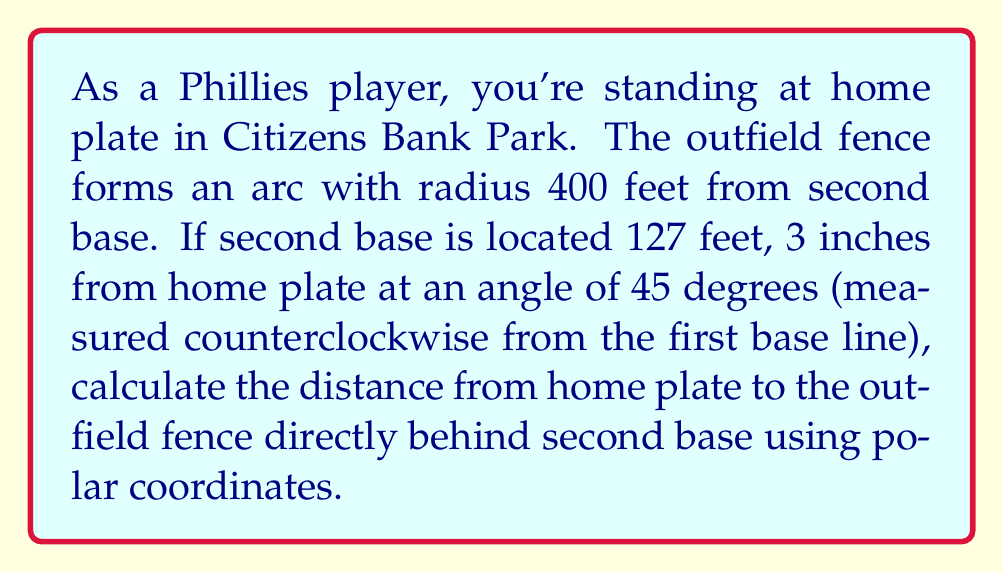What is the answer to this math problem? To solve this problem, we'll use polar coordinates and follow these steps:

1) First, we need to convert the given information into polar coordinates with home plate as the origin.

2) The position of second base in polar coordinates:
   $r_1 = 127.25$ feet (127 feet, 3 inches)
   $\theta_1 = 45°$

3) The outfield fence forms an arc centered at second base with radius 400 feet. We need to find the point on this arc that's directly behind second base from home plate's perspective.

4) To do this, we'll use the polar form of the equation of a circle:
   $r^2 + r_1^2 - 2rr_1\cos(\theta - \theta_1) = R^2$

   Where:
   $r, \theta$ are the polar coordinates of the point we're looking for
   $r_1, \theta_1$ are the polar coordinates of second base
   $R = 400$ feet (radius of the arc)

5) Since we're looking for the point directly behind second base, $\theta = \theta_1 = 45°$, so $\theta - \theta_1 = 0$

6) Substituting these values:
   $r^2 + 127.25^2 - 2r(127.25)\cos(0) = 400^2$

7) Simplifying:
   $r^2 + 16192.5625 - 254.5r = 160000$

8) Rearranging:
   $r^2 - 254.5r - 143807.4375 = 0$

9) This is a quadratic equation. We can solve it using the quadratic formula:
   $r = \frac{-b \pm \sqrt{b^2 - 4ac}}{2a}$

   Where $a = 1$, $b = -254.5$, and $c = -143807.4375$

10) Solving:
    $r = \frac{254.5 \pm \sqrt{64730.25 + 575229.75}}{2}$
    $r = \frac{254.5 \pm \sqrt{639960}}{2}$
    $r = \frac{254.5 \pm 800}{2}$

11) This gives us two solutions: $r = 527.25$ or $r = -272.75$

12) Since distance can't be negative, our solution is $r = 527.25$ feet.
Answer: The distance from home plate to the outfield fence directly behind second base is approximately 527.25 feet. 